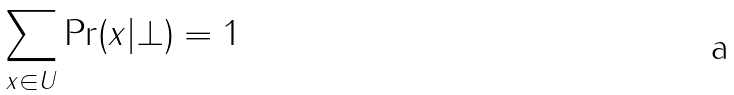<formula> <loc_0><loc_0><loc_500><loc_500>\sum _ { x \in U } \Pr ( x | \bot ) = 1</formula> 